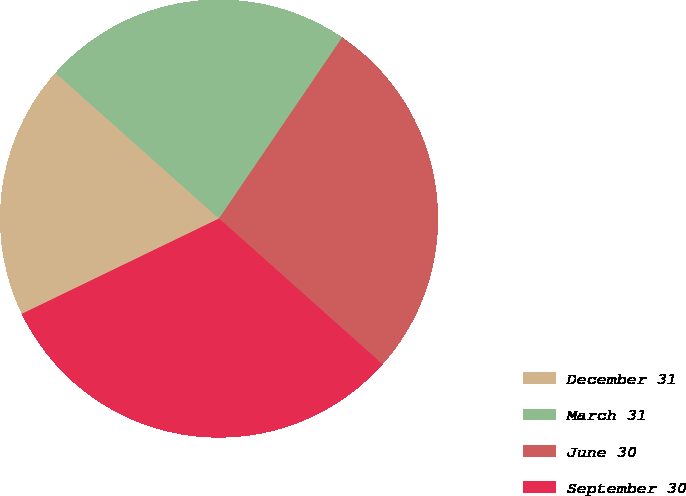Convert chart to OTSL. <chart><loc_0><loc_0><loc_500><loc_500><pie_chart><fcel>December 31<fcel>March 31<fcel>June 30<fcel>September 30<nl><fcel>18.75%<fcel>22.92%<fcel>27.08%<fcel>31.25%<nl></chart> 